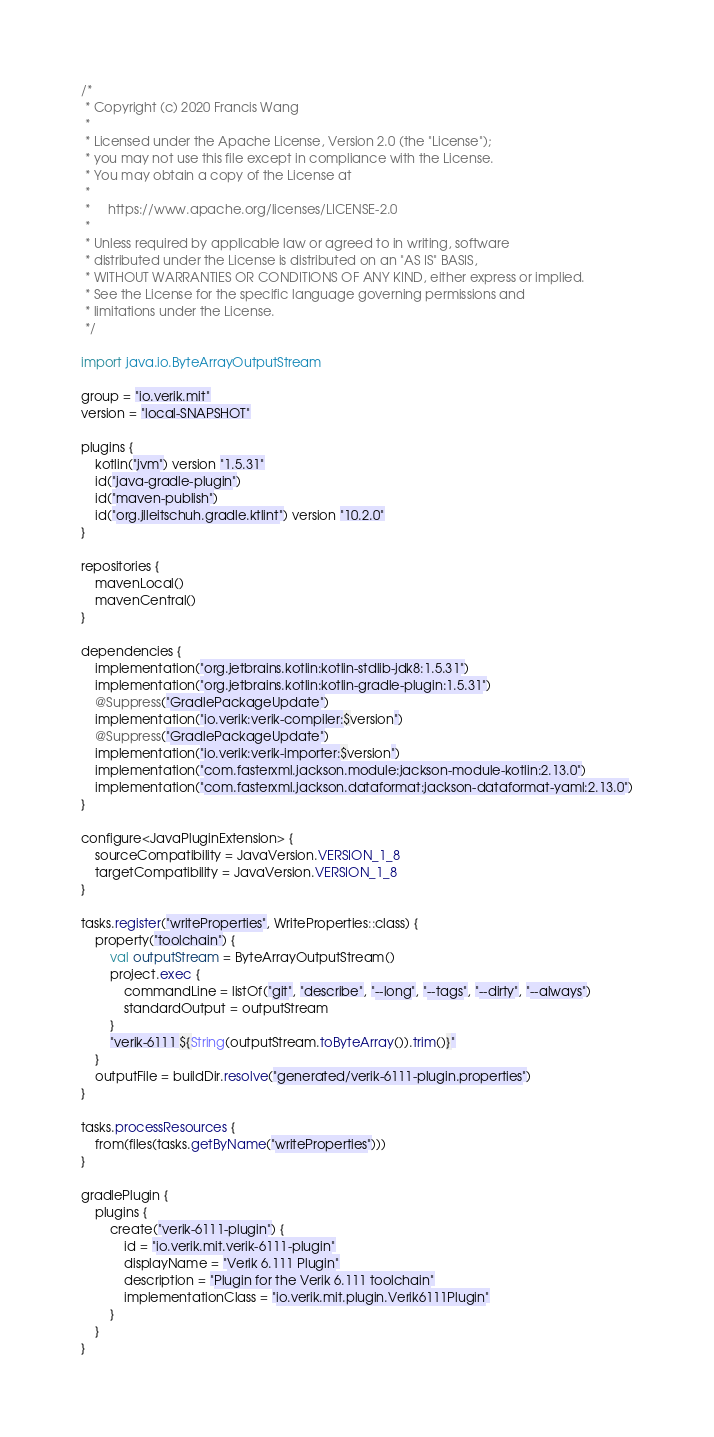<code> <loc_0><loc_0><loc_500><loc_500><_Kotlin_>/*
 * Copyright (c) 2020 Francis Wang
 *
 * Licensed under the Apache License, Version 2.0 (the "License");
 * you may not use this file except in compliance with the License.
 * You may obtain a copy of the License at
 *
 *     https://www.apache.org/licenses/LICENSE-2.0
 *
 * Unless required by applicable law or agreed to in writing, software
 * distributed under the License is distributed on an "AS IS" BASIS,
 * WITHOUT WARRANTIES OR CONDITIONS OF ANY KIND, either express or implied.
 * See the License for the specific language governing permissions and
 * limitations under the License.
 */

import java.io.ByteArrayOutputStream

group = "io.verik.mit"
version = "local-SNAPSHOT"

plugins {
    kotlin("jvm") version "1.5.31"
    id("java-gradle-plugin")
    id("maven-publish")
    id("org.jlleitschuh.gradle.ktlint") version "10.2.0"
}

repositories {
    mavenLocal()
    mavenCentral()
}

dependencies {
    implementation("org.jetbrains.kotlin:kotlin-stdlib-jdk8:1.5.31")
    implementation("org.jetbrains.kotlin:kotlin-gradle-plugin:1.5.31")
    @Suppress("GradlePackageUpdate")
    implementation("io.verik:verik-compiler:$version")
    @Suppress("GradlePackageUpdate")
    implementation("io.verik:verik-importer:$version")
    implementation("com.fasterxml.jackson.module:jackson-module-kotlin:2.13.0")
    implementation("com.fasterxml.jackson.dataformat:jackson-dataformat-yaml:2.13.0")
}

configure<JavaPluginExtension> {
    sourceCompatibility = JavaVersion.VERSION_1_8
    targetCompatibility = JavaVersion.VERSION_1_8
}

tasks.register("writeProperties", WriteProperties::class) {
    property("toolchain") {
        val outputStream = ByteArrayOutputStream()
        project.exec {
            commandLine = listOf("git", "describe", "--long", "--tags", "--dirty", "--always")
            standardOutput = outputStream
        }
        "verik-6111 ${String(outputStream.toByteArray()).trim()}"
    }
    outputFile = buildDir.resolve("generated/verik-6111-plugin.properties")
}

tasks.processResources {
    from(files(tasks.getByName("writeProperties")))
}

gradlePlugin {
    plugins {
        create("verik-6111-plugin") {
            id = "io.verik.mit.verik-6111-plugin"
            displayName = "Verik 6.111 Plugin"
            description = "Plugin for the Verik 6.111 toolchain"
            implementationClass = "io.verik.mit.plugin.Verik6111Plugin"
        }
    }
}
</code> 